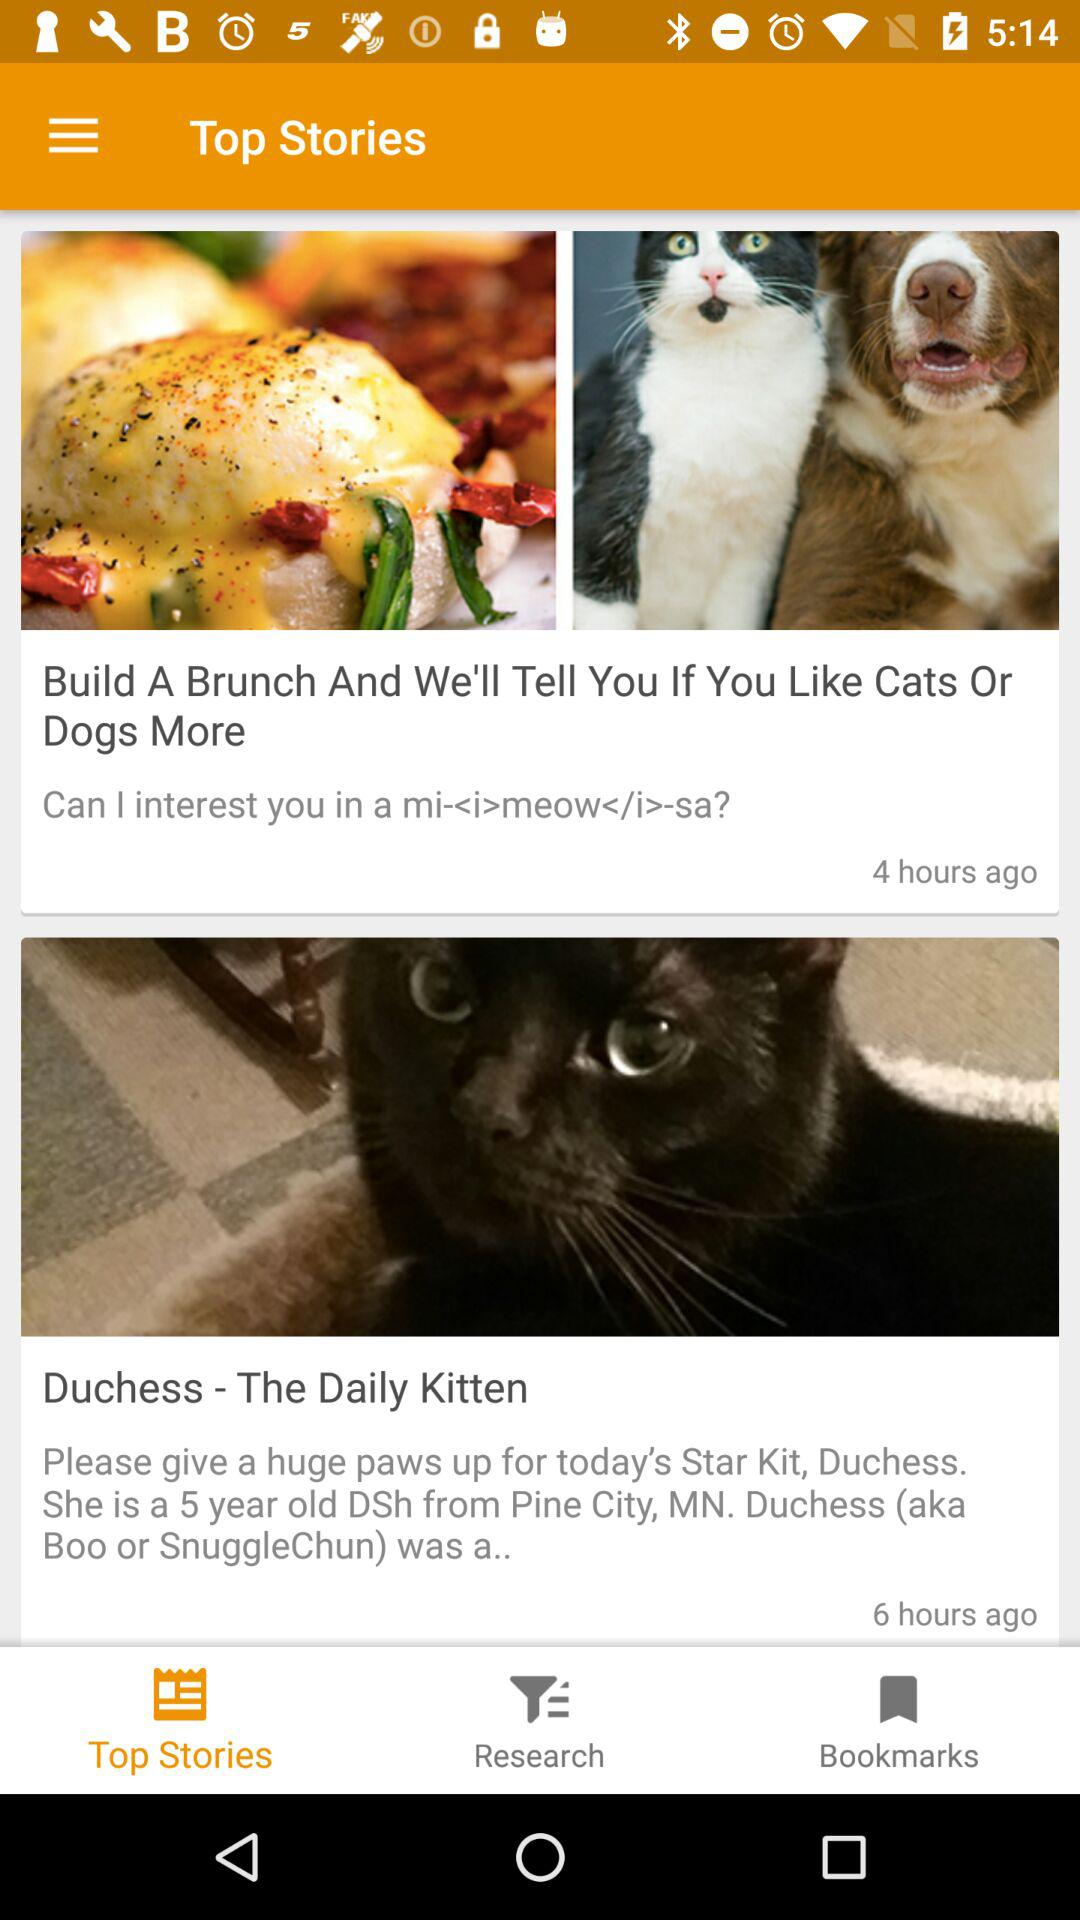How many hours ago was the "Duchess - The Daily Kitten" posted? The "Duchess - The Daily Kitten" was posted 6 hours ago. 